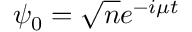Convert formula to latex. <formula><loc_0><loc_0><loc_500><loc_500>\psi _ { 0 } = { \sqrt { n } } e ^ { - i \mu t }</formula> 